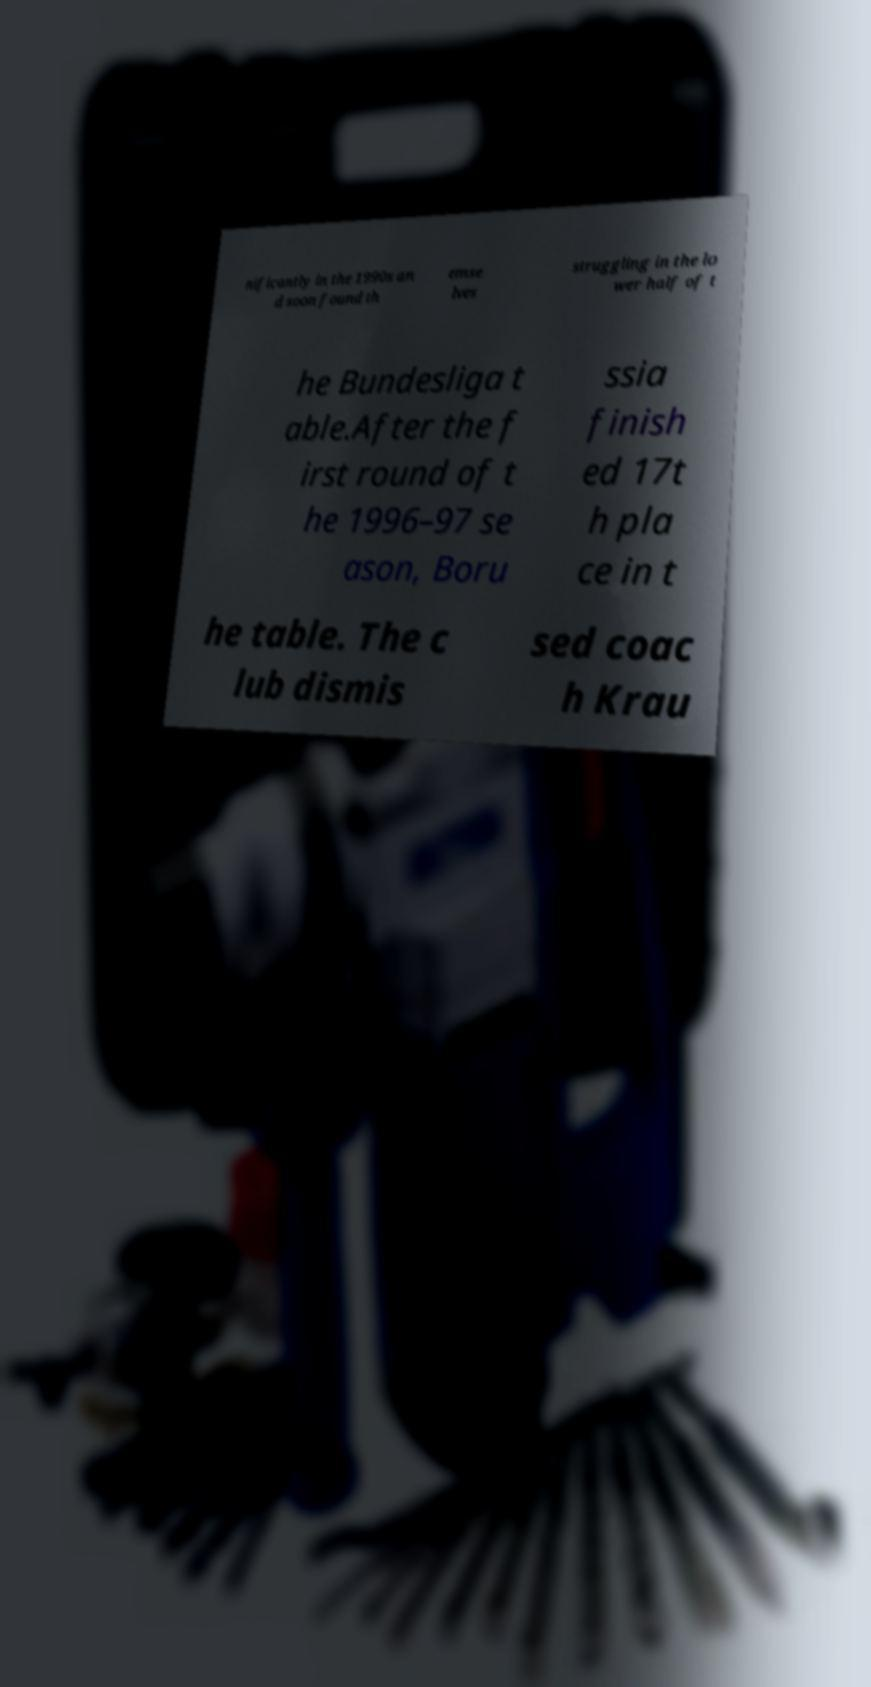Please read and relay the text visible in this image. What does it say? nificantly in the 1990s an d soon found th emse lves struggling in the lo wer half of t he Bundesliga t able.After the f irst round of t he 1996–97 se ason, Boru ssia finish ed 17t h pla ce in t he table. The c lub dismis sed coac h Krau 